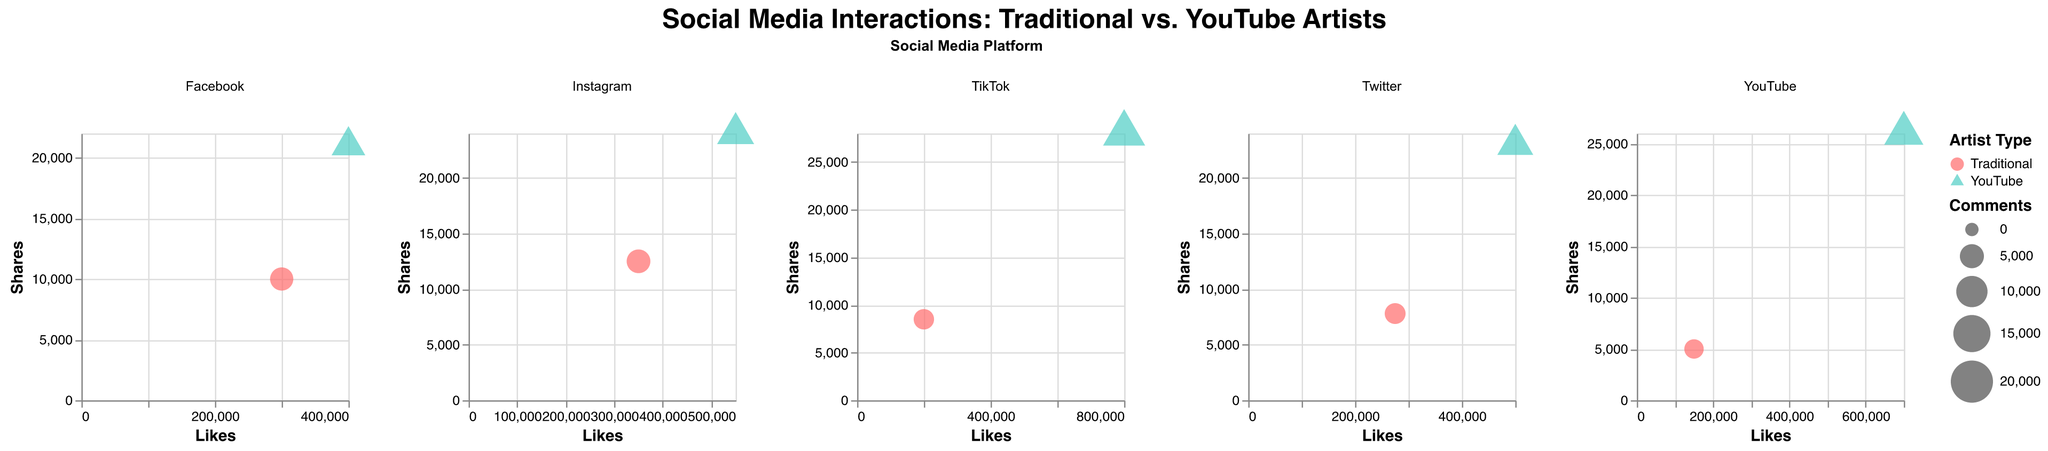What is the title of the figure? The title is located at the top center of the figure. It summarizes the main topic of the figure by stating, "Social Media Interactions: Traditional vs. YouTube Artists."
Answer: Social Media Interactions: Traditional vs. YouTube Artists Which artist has the highest number of likes on TikTok? On TikTok, the size of the bubbles varies, and the like counts indicate that ZHC, who is a YouTube artist, has the highest number of likes. The bubble representing ZHC is larger and is marked with more likes.
Answer: ZHC What is the relationship between the number of likes and shares on Instagram for traditional and YouTube artists? By plotting the number of likes on the x-axis and shares on the y-axis for Instagram, it is evident that Bob Ross (YouTube artist) has a higher number of both likes and shares compared to Pablo Picasso (Traditional artist).
Answer: Bob Ross has more likes and shares than Pablo Picasso Which social media platform shows the largest bubble for YouTube artists? The largest bubble represents the highest number of comments. Here, TikTok has the largest bubble for ZHC, indicating that he has the most comments among YouTube artists across all platforms.
Answer: TikTok Compare the number of shares for Claude Monet on YouTube with Frida Kahlo on Twitter. Two bubbles represent Claude Monet and Frida Kahlo on their respective platforms. Claude Monet has 5,000 shares on YouTube, while Frida Kahlo has 7,800 shares on Twitter. Frida Kahlo has more shares.
Answer: Frida Kahlo has more shares How do the shapes and colors differ between traditional and YouTube artists on Facebook? Traditional artists are shown with circular shapes and a specific color, while YouTube artists are represented with triangular shapes and another distinctive color. The bubbles for Leonardo da Vinci (Traditional) and Casey Neistat (YouTube) reflect these differences.
Answer: Circles for traditional, triangles for YouTube; different colors Which traditional artist has the highest number of likes on any platform? Comparing the number of likes across the different subplots (platforms) for traditional artists, Pablo Picasso on Instagram has the highest number of likes (350,000 likes).
Answer: Pablo Picasso What pattern can be observed in the number of comments for YouTube artists across different platforms? By examining the size of the bubbles (which represents comments) for YouTube artists across platforms, we can see that TikTok (ZHC) has the most comments, followed by YouTube (Vexx), Instagram (Bob Ross), Facebook (Casey Neistat), and Twitter (Peter McKinnon). The pattern shows an increase from Twitter to TikTok.
Answer: Increasing from Twitter to TikTok 